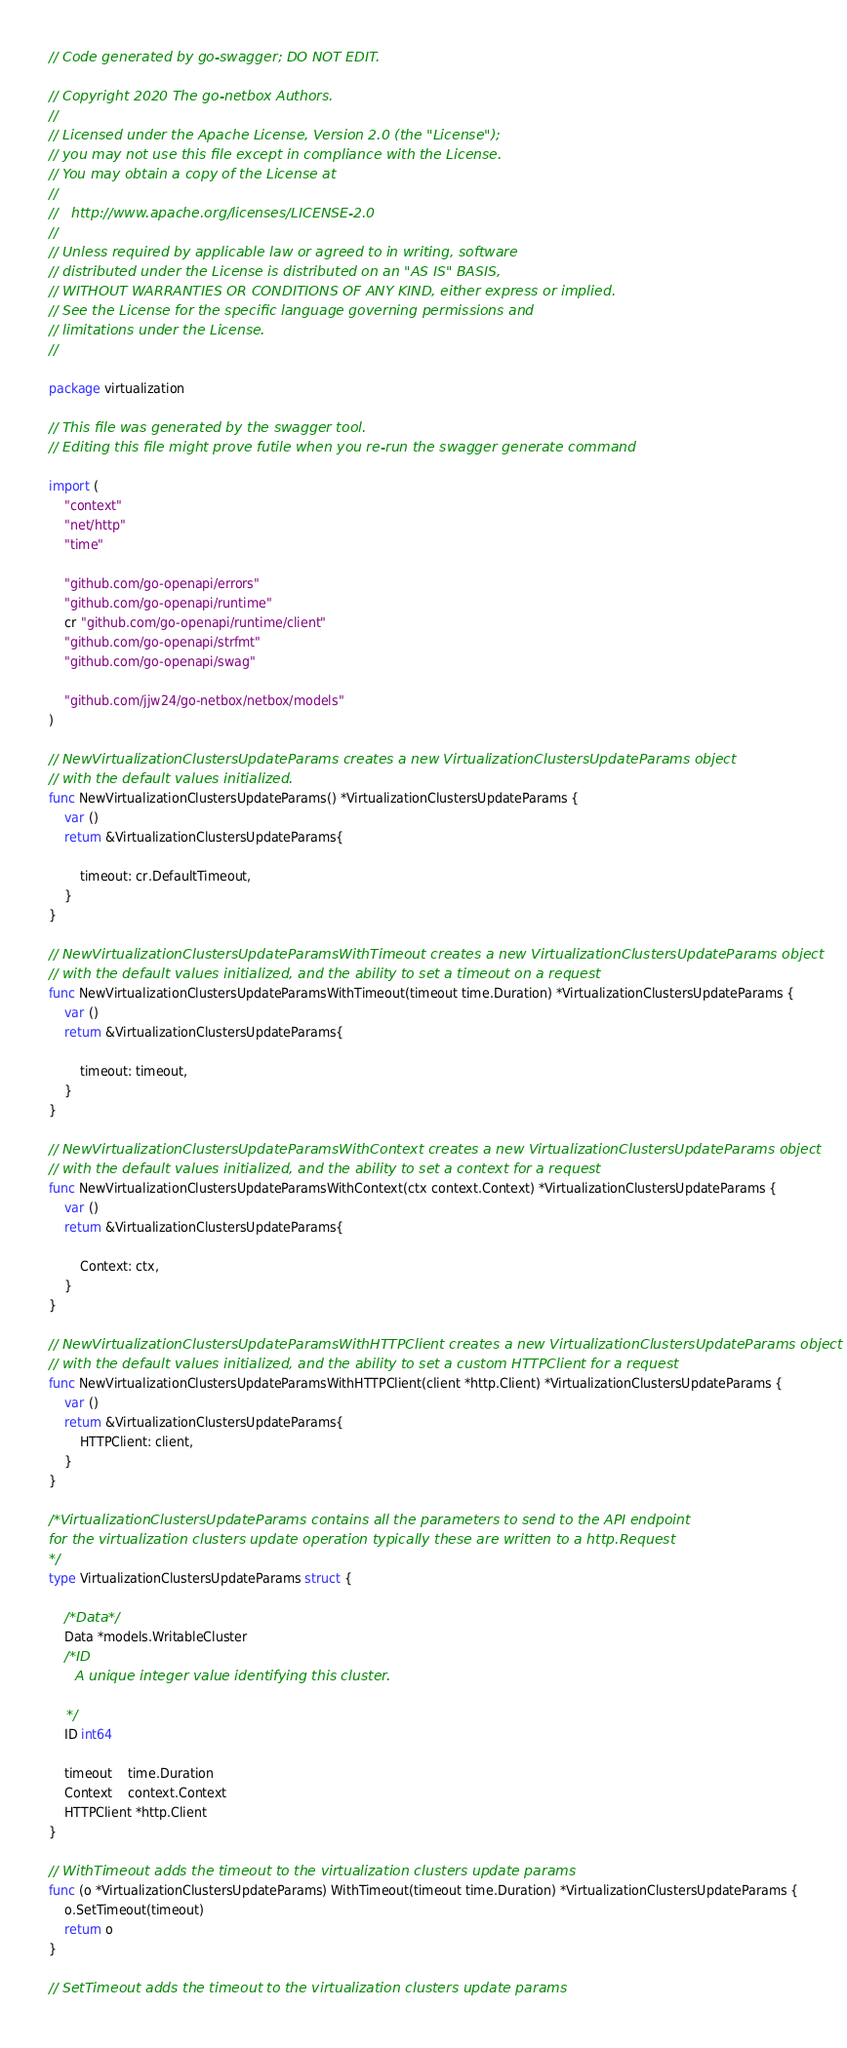Convert code to text. <code><loc_0><loc_0><loc_500><loc_500><_Go_>// Code generated by go-swagger; DO NOT EDIT.

// Copyright 2020 The go-netbox Authors.
//
// Licensed under the Apache License, Version 2.0 (the "License");
// you may not use this file except in compliance with the License.
// You may obtain a copy of the License at
//
//   http://www.apache.org/licenses/LICENSE-2.0
//
// Unless required by applicable law or agreed to in writing, software
// distributed under the License is distributed on an "AS IS" BASIS,
// WITHOUT WARRANTIES OR CONDITIONS OF ANY KIND, either express or implied.
// See the License for the specific language governing permissions and
// limitations under the License.
//

package virtualization

// This file was generated by the swagger tool.
// Editing this file might prove futile when you re-run the swagger generate command

import (
	"context"
	"net/http"
	"time"

	"github.com/go-openapi/errors"
	"github.com/go-openapi/runtime"
	cr "github.com/go-openapi/runtime/client"
	"github.com/go-openapi/strfmt"
	"github.com/go-openapi/swag"

	"github.com/jjw24/go-netbox/netbox/models"
)

// NewVirtualizationClustersUpdateParams creates a new VirtualizationClustersUpdateParams object
// with the default values initialized.
func NewVirtualizationClustersUpdateParams() *VirtualizationClustersUpdateParams {
	var ()
	return &VirtualizationClustersUpdateParams{

		timeout: cr.DefaultTimeout,
	}
}

// NewVirtualizationClustersUpdateParamsWithTimeout creates a new VirtualizationClustersUpdateParams object
// with the default values initialized, and the ability to set a timeout on a request
func NewVirtualizationClustersUpdateParamsWithTimeout(timeout time.Duration) *VirtualizationClustersUpdateParams {
	var ()
	return &VirtualizationClustersUpdateParams{

		timeout: timeout,
	}
}

// NewVirtualizationClustersUpdateParamsWithContext creates a new VirtualizationClustersUpdateParams object
// with the default values initialized, and the ability to set a context for a request
func NewVirtualizationClustersUpdateParamsWithContext(ctx context.Context) *VirtualizationClustersUpdateParams {
	var ()
	return &VirtualizationClustersUpdateParams{

		Context: ctx,
	}
}

// NewVirtualizationClustersUpdateParamsWithHTTPClient creates a new VirtualizationClustersUpdateParams object
// with the default values initialized, and the ability to set a custom HTTPClient for a request
func NewVirtualizationClustersUpdateParamsWithHTTPClient(client *http.Client) *VirtualizationClustersUpdateParams {
	var ()
	return &VirtualizationClustersUpdateParams{
		HTTPClient: client,
	}
}

/*VirtualizationClustersUpdateParams contains all the parameters to send to the API endpoint
for the virtualization clusters update operation typically these are written to a http.Request
*/
type VirtualizationClustersUpdateParams struct {

	/*Data*/
	Data *models.WritableCluster
	/*ID
	  A unique integer value identifying this cluster.

	*/
	ID int64

	timeout    time.Duration
	Context    context.Context
	HTTPClient *http.Client
}

// WithTimeout adds the timeout to the virtualization clusters update params
func (o *VirtualizationClustersUpdateParams) WithTimeout(timeout time.Duration) *VirtualizationClustersUpdateParams {
	o.SetTimeout(timeout)
	return o
}

// SetTimeout adds the timeout to the virtualization clusters update params</code> 